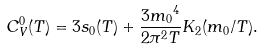Convert formula to latex. <formula><loc_0><loc_0><loc_500><loc_500>C _ { V } ^ { 0 } ( T ) = 3 s _ { 0 } ( T ) + \frac { { 3 m _ { 0 } } ^ { 4 } } { 2 { \pi } ^ { 2 } T } K _ { 2 } ( m _ { 0 } / T ) .</formula> 